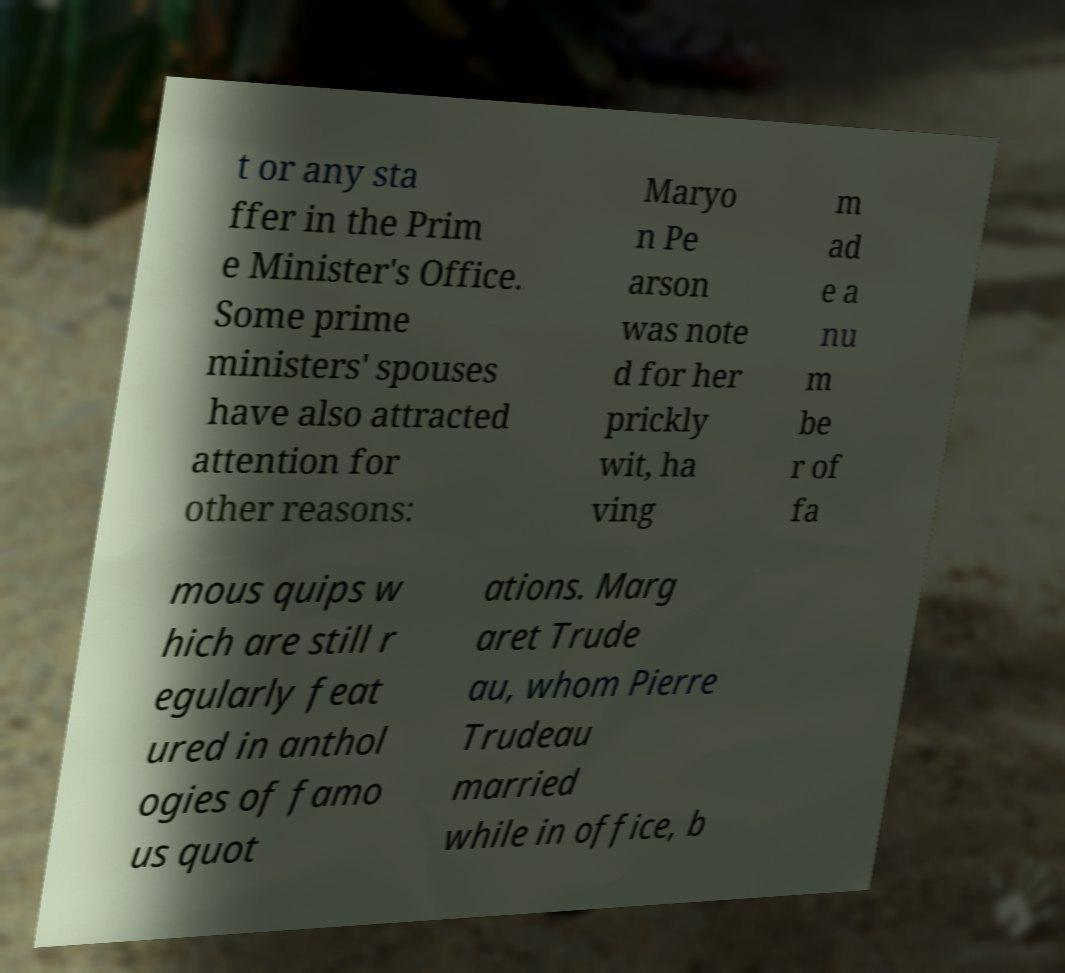What messages or text are displayed in this image? I need them in a readable, typed format. t or any sta ffer in the Prim e Minister's Office. Some prime ministers' spouses have also attracted attention for other reasons: Maryo n Pe arson was note d for her prickly wit, ha ving m ad e a nu m be r of fa mous quips w hich are still r egularly feat ured in anthol ogies of famo us quot ations. Marg aret Trude au, whom Pierre Trudeau married while in office, b 